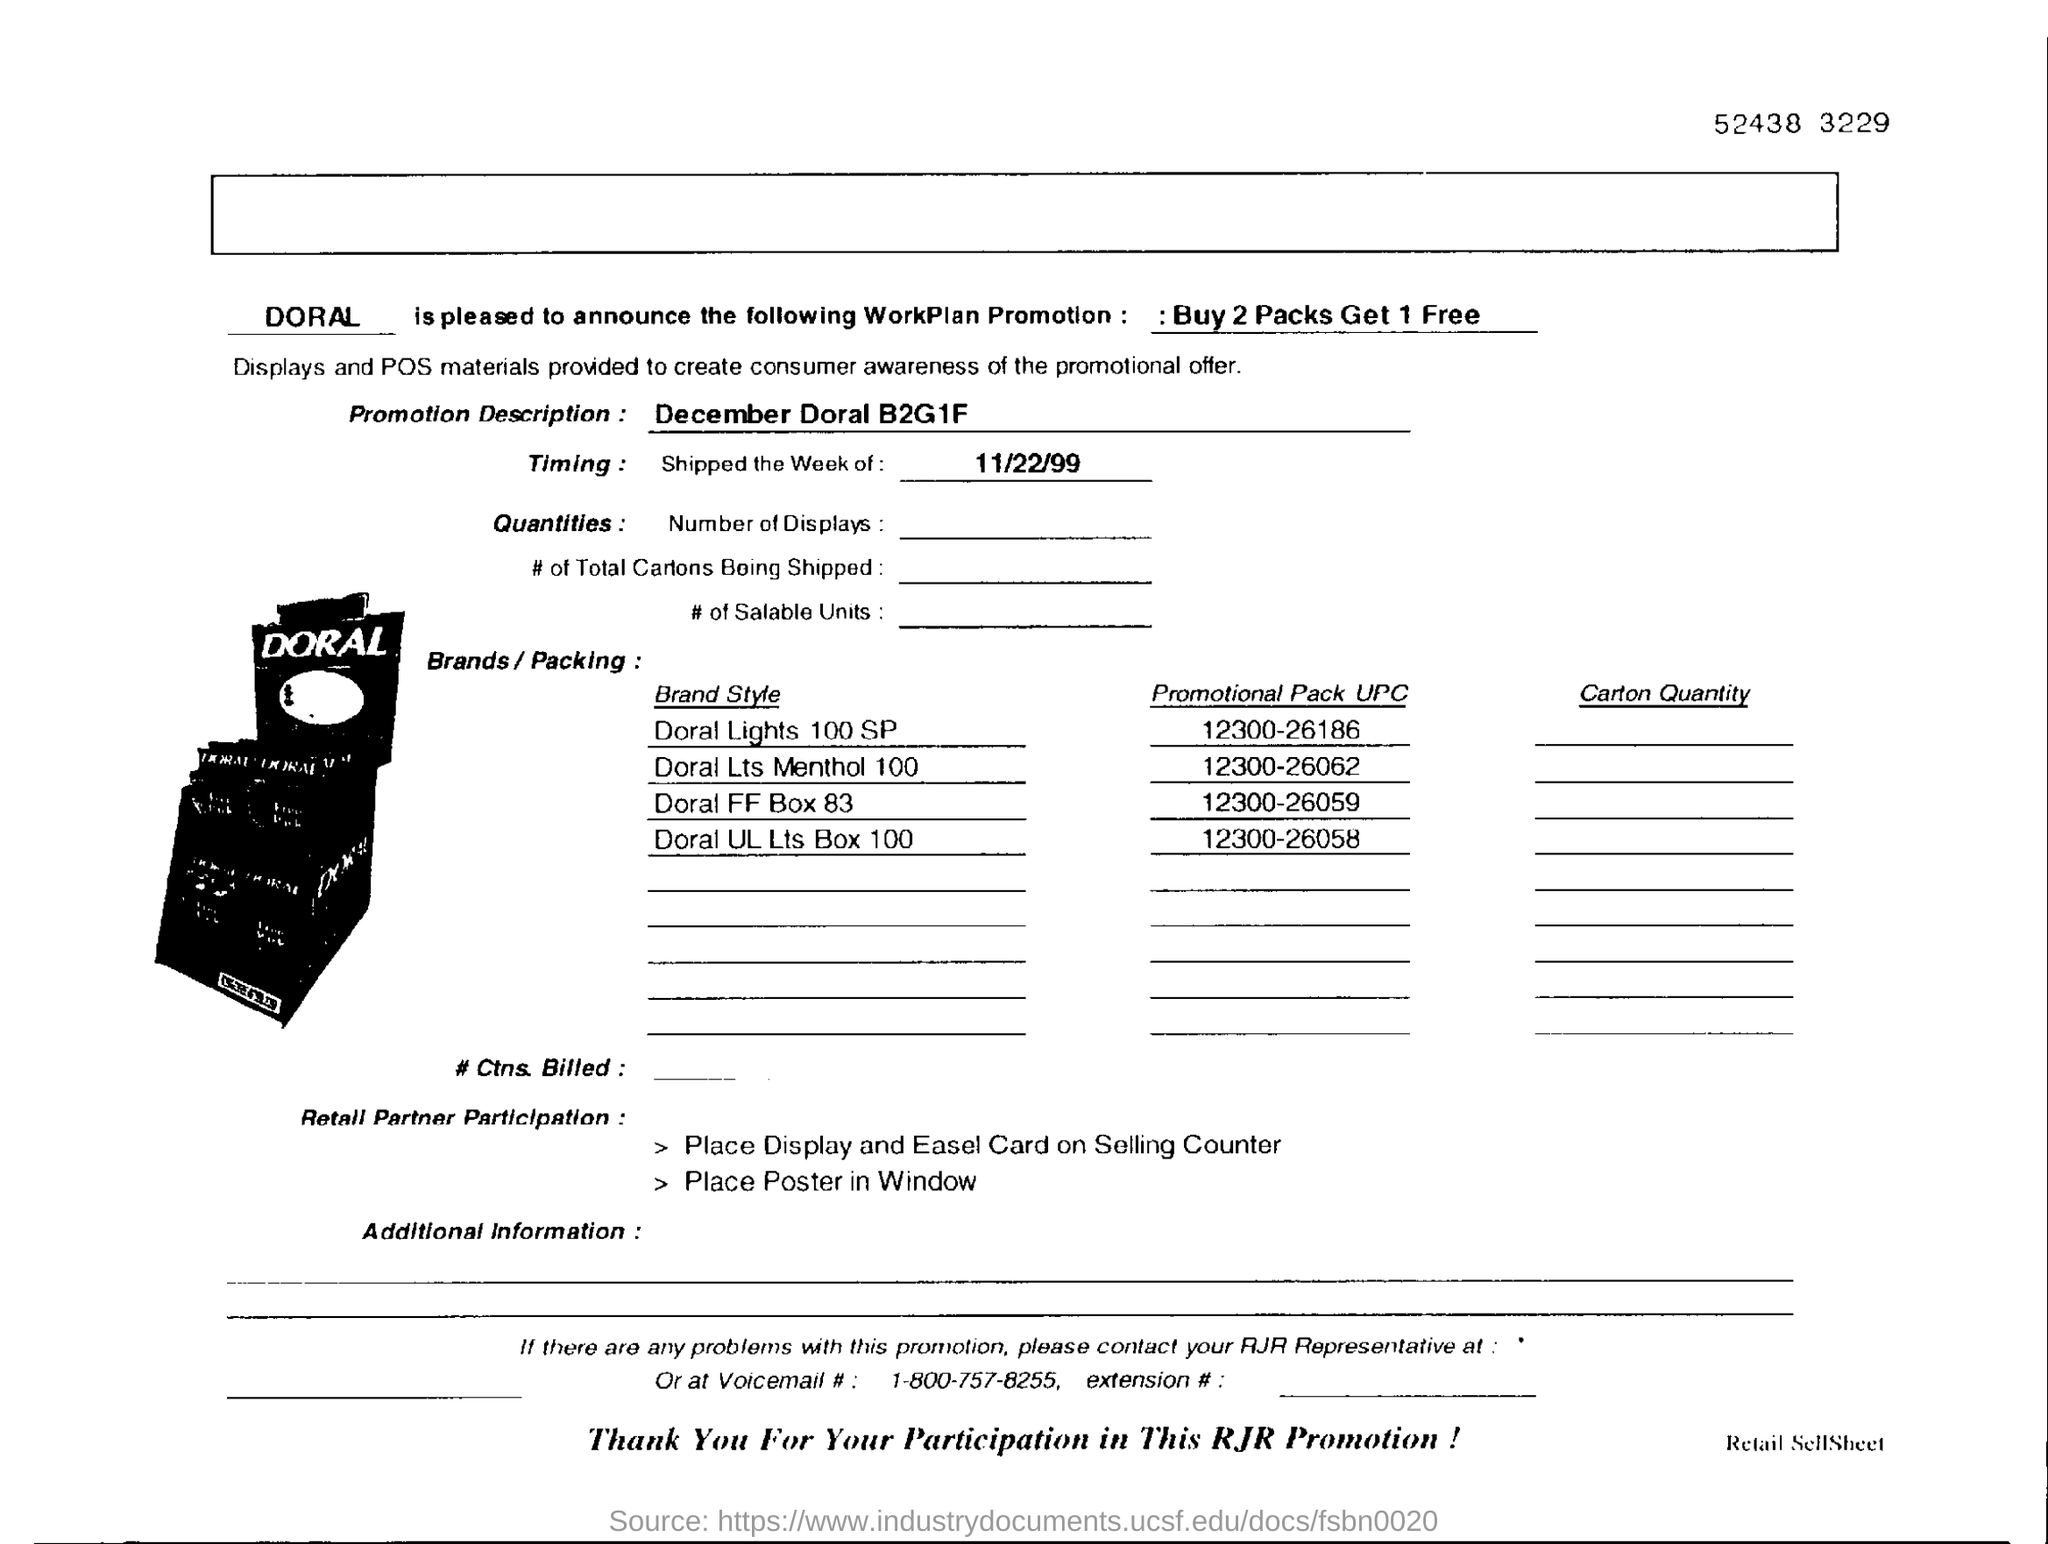Which brand is this ?
Offer a very short reply. DORAL. What is the WorkPlan Promotion ?
Keep it short and to the point. Buy 2 packs get 1 free. What is the Promotion Description ?
Ensure brevity in your answer.  December Doral B2G1F. What is the UPC number for Doral FF Box 83 ?
Provide a short and direct response. 12300-26059. 